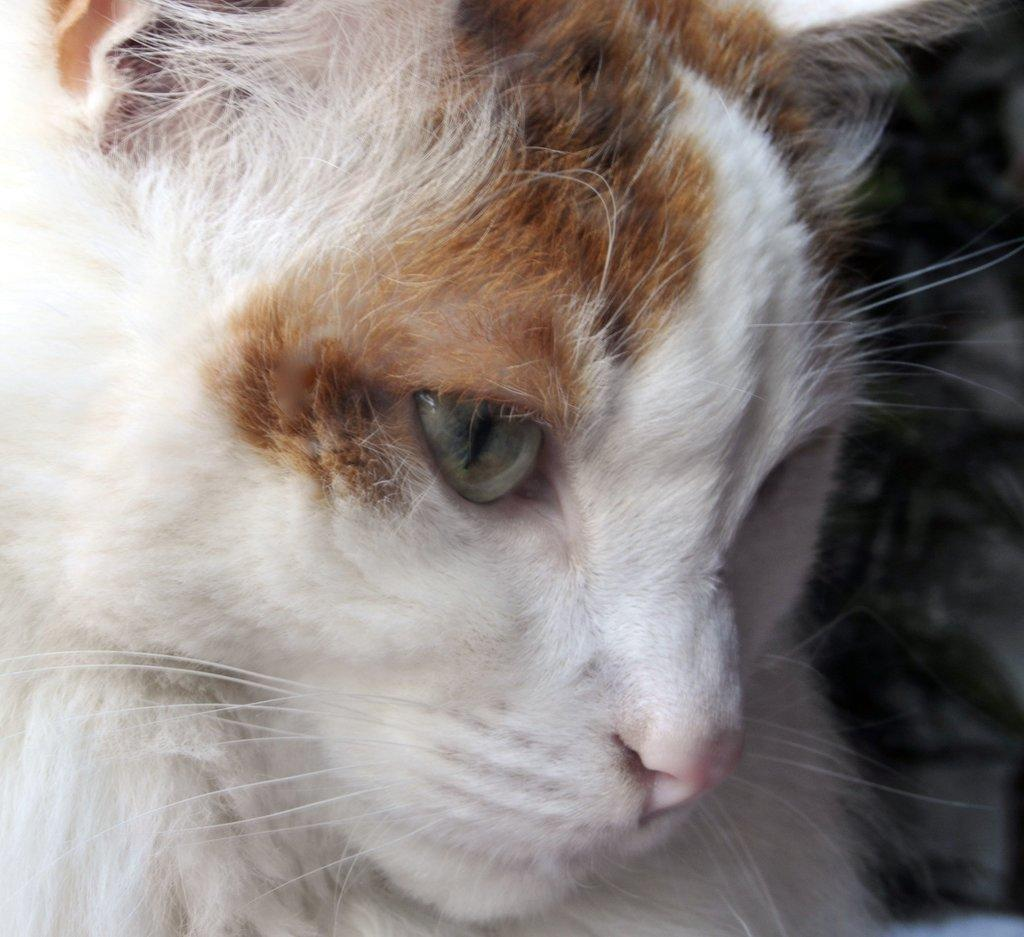What type of animal is in the image? There is a cat in the image. Can you describe the coloring of the cat? The cat has brown and white coloring. What sound does the tiger make in the image? There is no tiger present in the image; it features a cat. 